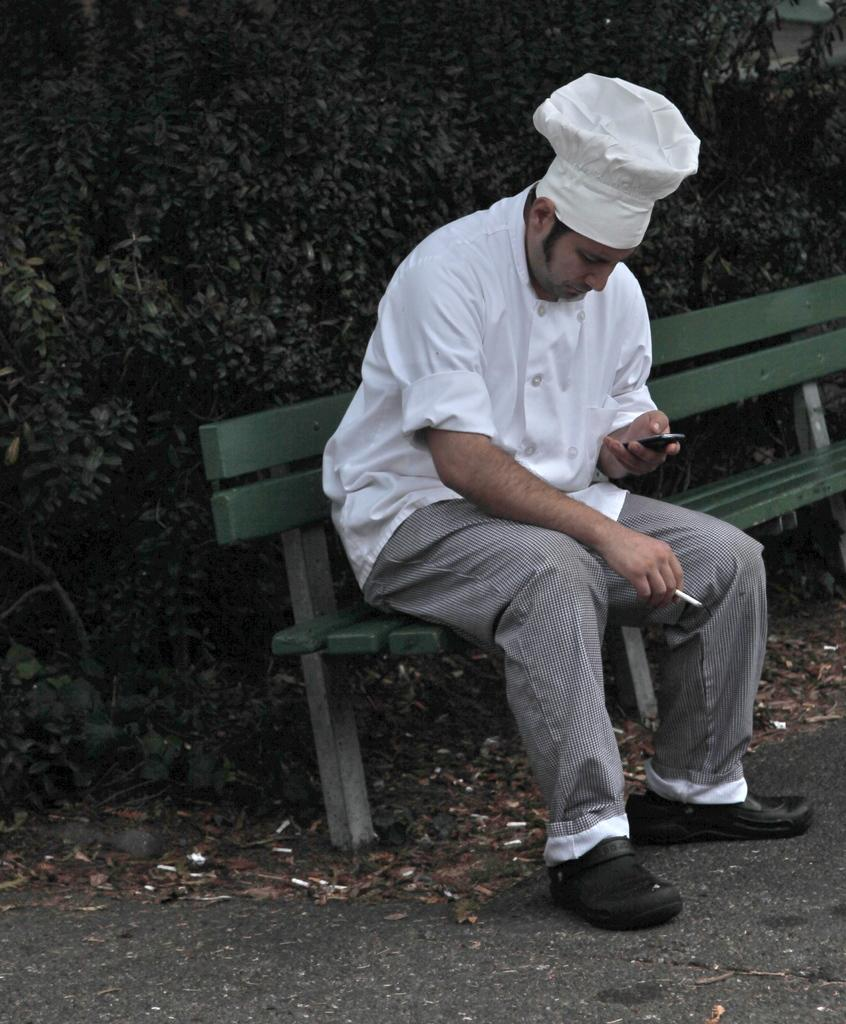Where was the image taken? The image was taken on the road. What is the man in the image doing? The man is sitting on a bench in the center of the image. What is the man holding in his hand? The man is holding a mobile in his hand. What can be seen in the background of the image? There is a tree in the background of the image. What type of bell can be heard ringing in the image? There is no bell present or ringing in the image. Is the man's sister sitting next to him on the bench in the image? The provided facts do not mention the man's sister, so it cannot be determined if she is present in the image. 